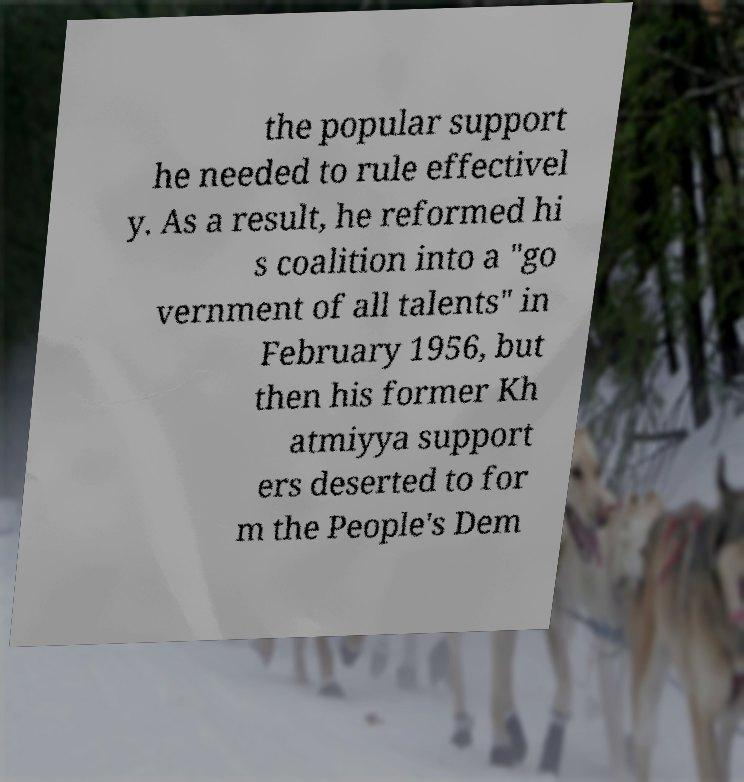What messages or text are displayed in this image? I need them in a readable, typed format. the popular support he needed to rule effectivel y. As a result, he reformed hi s coalition into a "go vernment of all talents" in February 1956, but then his former Kh atmiyya support ers deserted to for m the People's Dem 